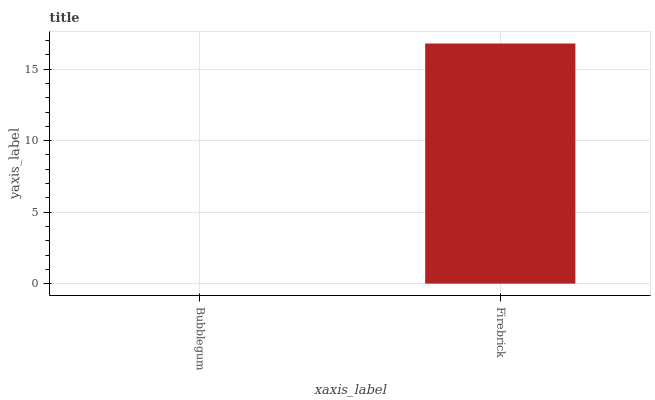Is Bubblegum the minimum?
Answer yes or no. Yes. Is Firebrick the maximum?
Answer yes or no. Yes. Is Firebrick the minimum?
Answer yes or no. No. Is Firebrick greater than Bubblegum?
Answer yes or no. Yes. Is Bubblegum less than Firebrick?
Answer yes or no. Yes. Is Bubblegum greater than Firebrick?
Answer yes or no. No. Is Firebrick less than Bubblegum?
Answer yes or no. No. Is Firebrick the high median?
Answer yes or no. Yes. Is Bubblegum the low median?
Answer yes or no. Yes. Is Bubblegum the high median?
Answer yes or no. No. Is Firebrick the low median?
Answer yes or no. No. 